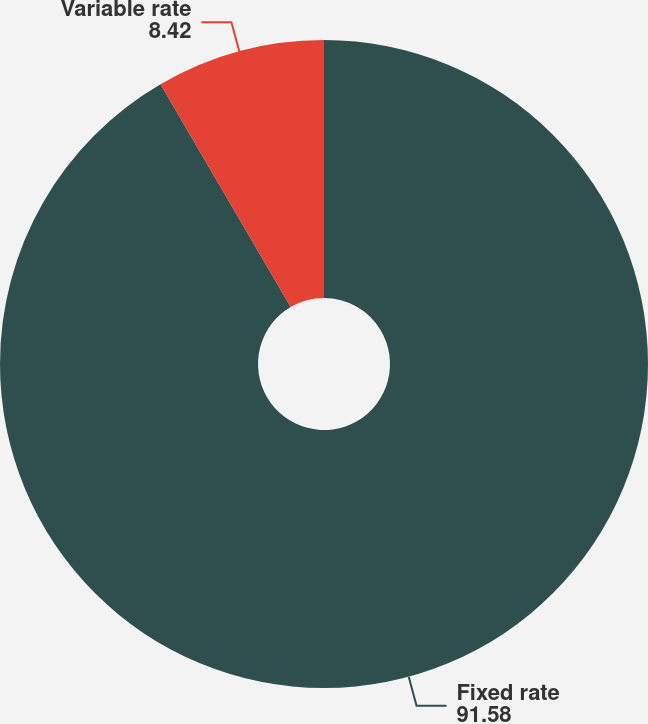<chart> <loc_0><loc_0><loc_500><loc_500><pie_chart><fcel>Fixed rate<fcel>Variable rate<nl><fcel>91.58%<fcel>8.42%<nl></chart> 